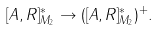Convert formula to latex. <formula><loc_0><loc_0><loc_500><loc_500>[ A , R ] ^ { * } _ { M _ { 2 } } \to ( [ A , R ] ^ { * } _ { M _ { 2 } } ) ^ { + } .</formula> 